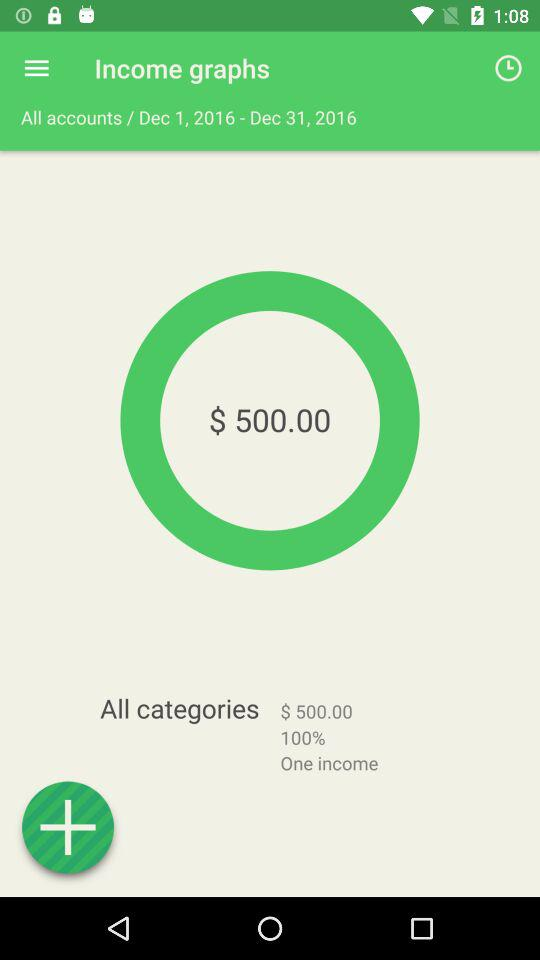What is the year for which the calculation of income is shown? The year for which the calculation of income is shown is 2016. 